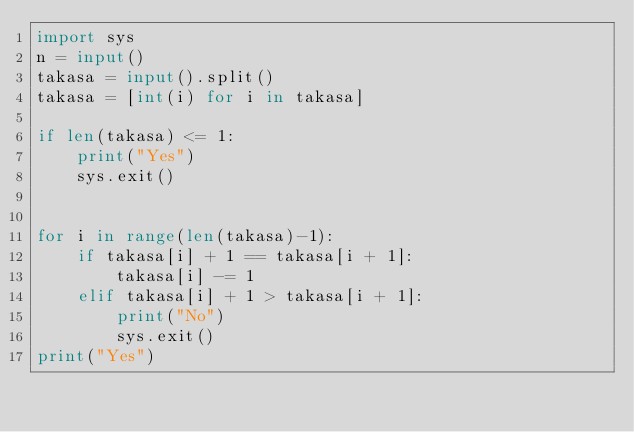<code> <loc_0><loc_0><loc_500><loc_500><_Python_>import sys
n = input()
takasa = input().split()
takasa = [int(i) for i in takasa]

if len(takasa) <= 1:
    print("Yes")
    sys.exit()


for i in range(len(takasa)-1):
    if takasa[i] + 1 == takasa[i + 1]:
        takasa[i] -= 1
    elif takasa[i] + 1 > takasa[i + 1]:
        print("No")
        sys.exit()
print("Yes")</code> 